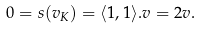<formula> <loc_0><loc_0><loc_500><loc_500>0 = s ( v _ { K } ) = \langle 1 , 1 \rangle . v = 2 v .</formula> 